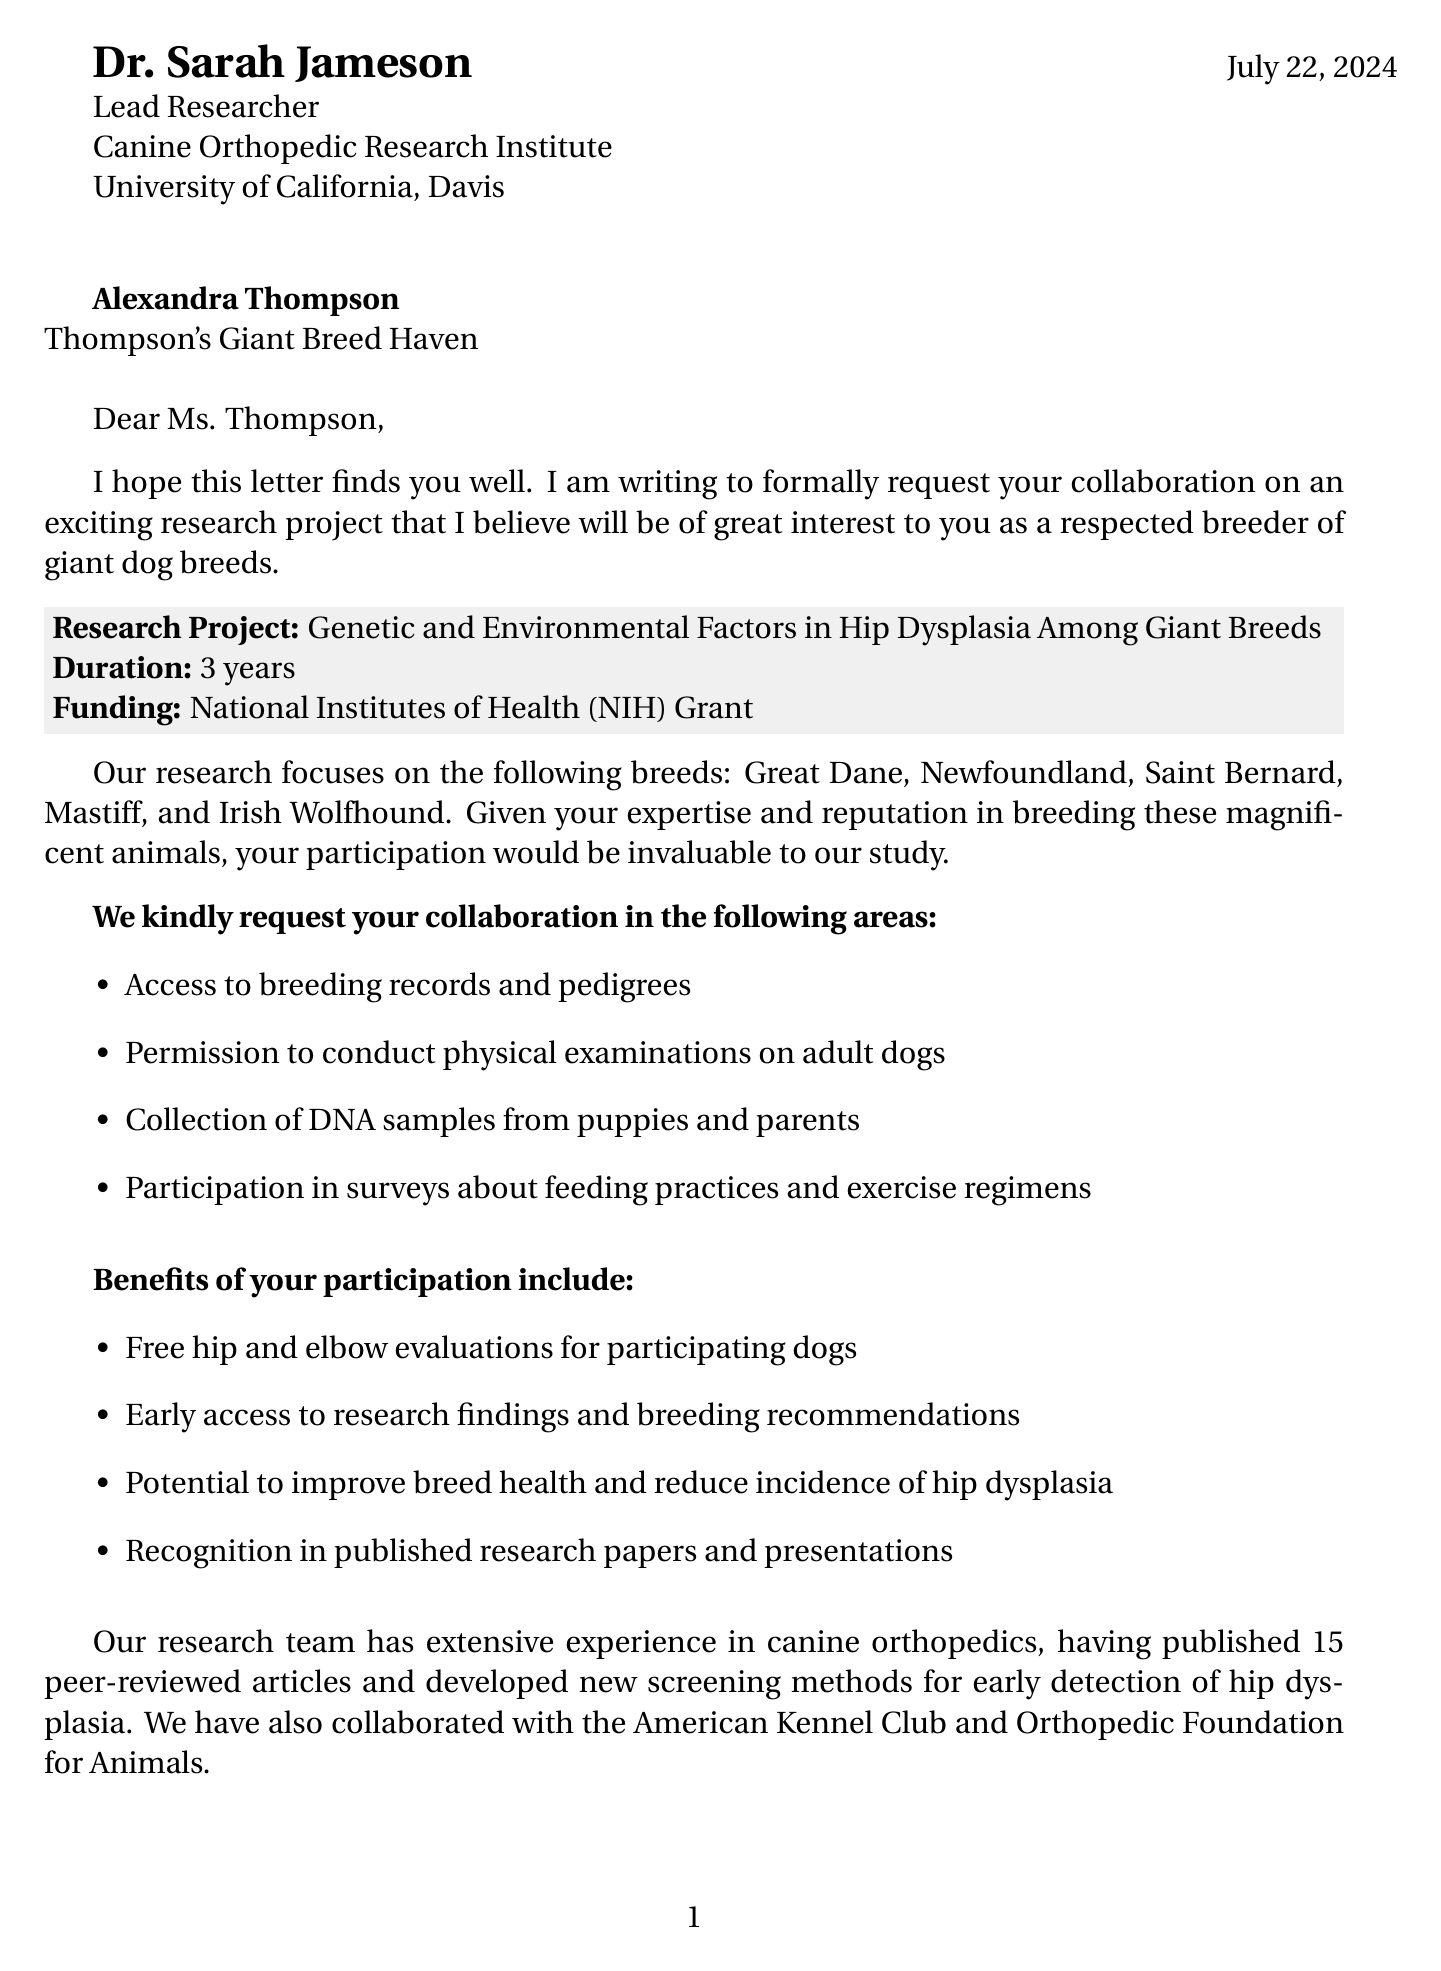What is the title of the research project? The title of the research project is stated in the document as "Genetic and Environmental Factors in Hip Dysplasia Among Giant Breeds."
Answer: Genetic and Environmental Factors in Hip Dysplasia Among Giant Breeds Who is the lead researcher? The document specifies that the lead researcher is Dr. Sarah Jameson.
Answer: Dr. Sarah Jameson What is the duration of the research project? The document indicates that the research project will last for 3 years.
Answer: 3 years What breeds are targeted in the research? The document lists the targeted breeds as Great Dane, Newfoundland, Saint Bernard, Mastiff, and Irish Wolfhound.
Answer: Great Dane, Newfoundland, Saint Bernard, Mastiff, Irish Wolfhound What type of evaluations will be provided for participating dogs? The document mentions that free hip and elbow evaluations will be provided for participating dogs.
Answer: Free hip and elbow evaluations What will happen three months after the agreement? According to the document, data collection will start three months from the agreement.
Answer: Data collection start What is the assurance given regarding data handling? The document assures that all data will be anonymized and handled in compliance with veterinary ethics guidelines.
Answer: All data will be anonymized What is the initial meeting timeline? The document proposes that the initial meeting will take place within the next month.
Answer: Within next month 